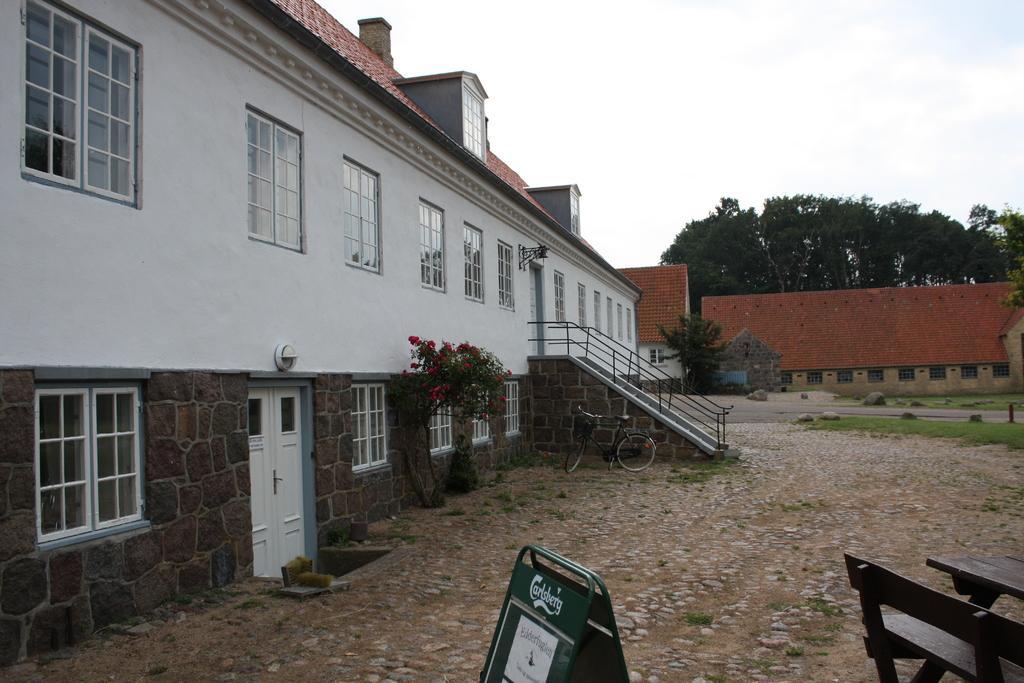Could you give a brief overview of what you see in this image? In this image on the left side there is one house, flower pots, plants and cycle. In the background there is a wall and trees, at the bottom there are some benches and boards and a walkway. On the top of the image there is sky. 